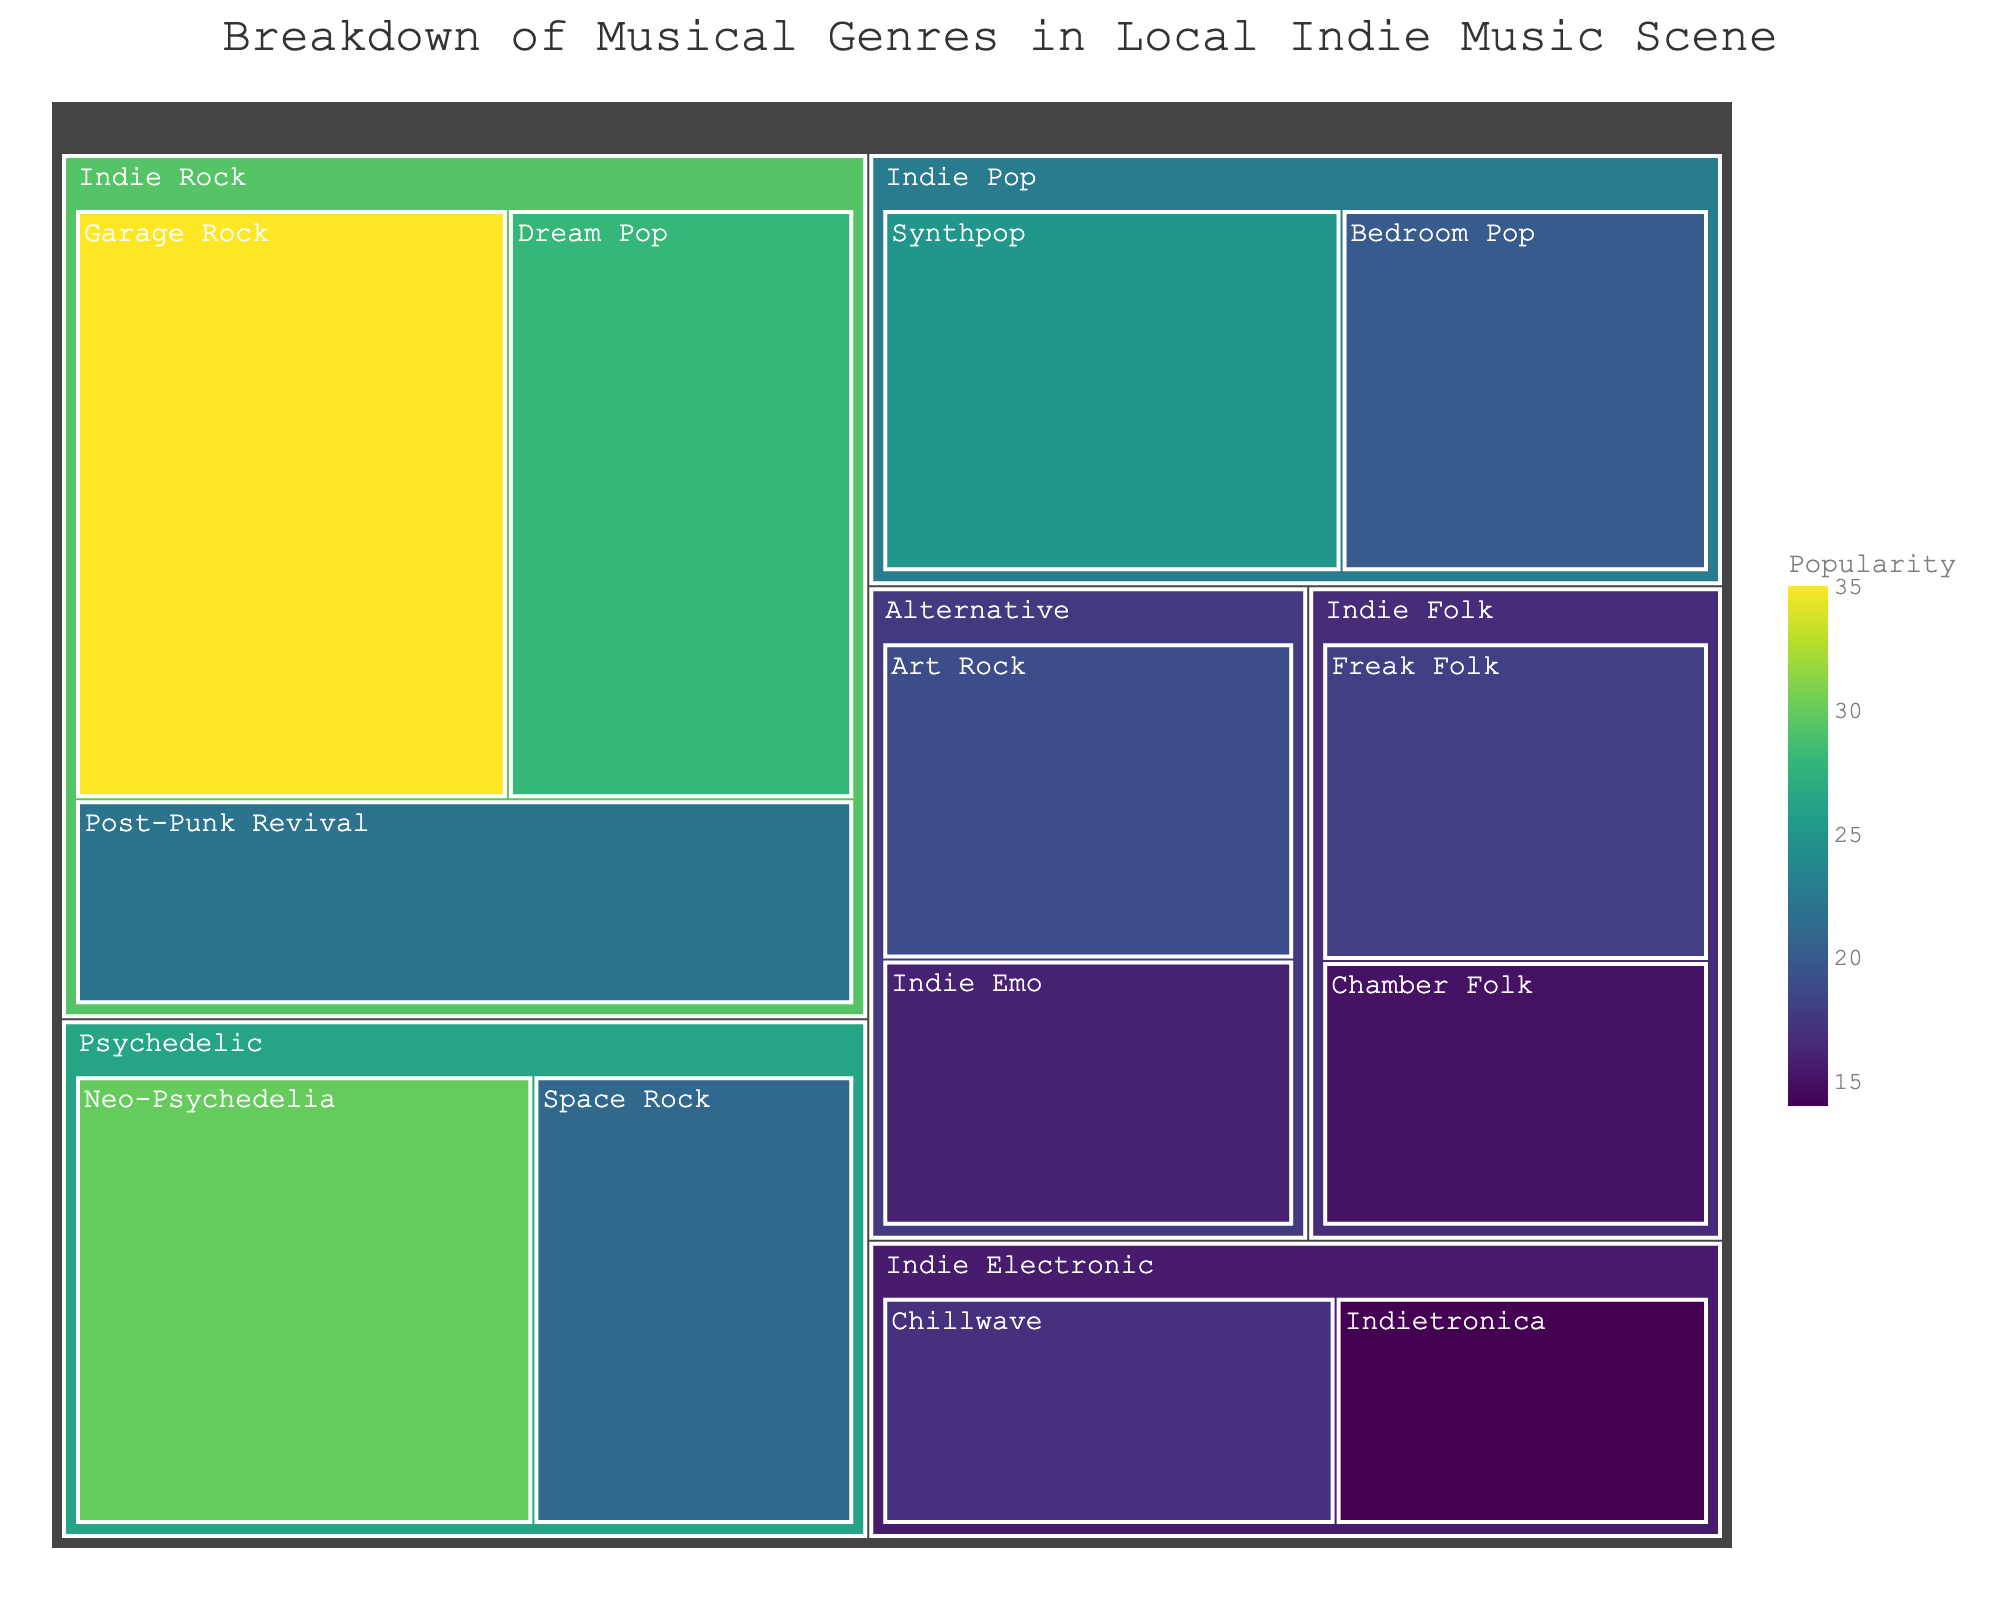What's the most popular subgenre in the Indie Rock genre? Look for the blocks within the "Indie Rock" section. The largest block indicates the subgenre with the highest popularity. In this case, "Garage Rock" has the highest value of 35.
Answer: Garage Rock Which subgenre under Psychedelic has more popularity: Neo-Psychedelia or Space Rock? Compare the popularity values of "Neo-Psychedelia" and "Space Rock" within the "Psychedelic" section. "Neo-Psychedelia" has a value of 30 and "Space Rock" has 21. Therefore, "Neo-Psychedelia" is more popular.
Answer: Neo-Psychedelia What is the total popularity of all Indie Folk subgenres combined? Add the popularity values of "Freak Folk" and "Chamber Folk" within the "Indie Folk" section. The calculation is 18 + 15 = 33.
Answer: 33 Which genre has the most subgenres? Count the subgenres under each main genre. Indie Rock has 3 subgenres, Indie Folk has 2, Indie Pop has 2, Indie Electronic has 2, Psychedelic has 2, and Alternative has 2. Indie Rock has the most subgenres.
Answer: Indie Rock What is the average popularity of the subgenres in Indie Pop? Add the popularity values of "Synthpop" and "Bedroom Pop" and then divide by the number of subgenres. The calculation is (25 + 20) / 2 = 45 / 2 = 22.5.
Answer: 22.5 Within the Alternative genre, which subgenre is less popular: Art Rock or Indie Emo? Compare the popularity values of "Art Rock" and "Indie Emo" within the "Alternative" section. "Art Rock" has a value of 19 and "Indie Emo" has 16, making "Indie Emo" less popular.
Answer: Indie Emo Which genre contributes most to the overall popularity? Sum up the popularity values of all subgenres within each main genre and compare. Indie Rock: 35 + 28 + 22 = 85; Indie Folk: 18 + 15 = 33; Indie Pop: 25 + 20 = 45; Indie Electronic: 17 + 14 = 31; Psychedelic: 30 + 21 = 51; Alternative: 19 + 16 = 35. Indie Rock has the highest total.
Answer: Indie Rock Which two main genres have the similar total popularity? Calculate the total popularity for each main genre and compare. Indie Rock: 85; Indie Folk: 33; Indie Pop: 45; Indie Electronic: 31; Psychedelic: 51; Alternative: 35. Indie Folk (33) and Indie Electronic (31) have similar totals.
Answer: Indie Folk and Indie Electronic 